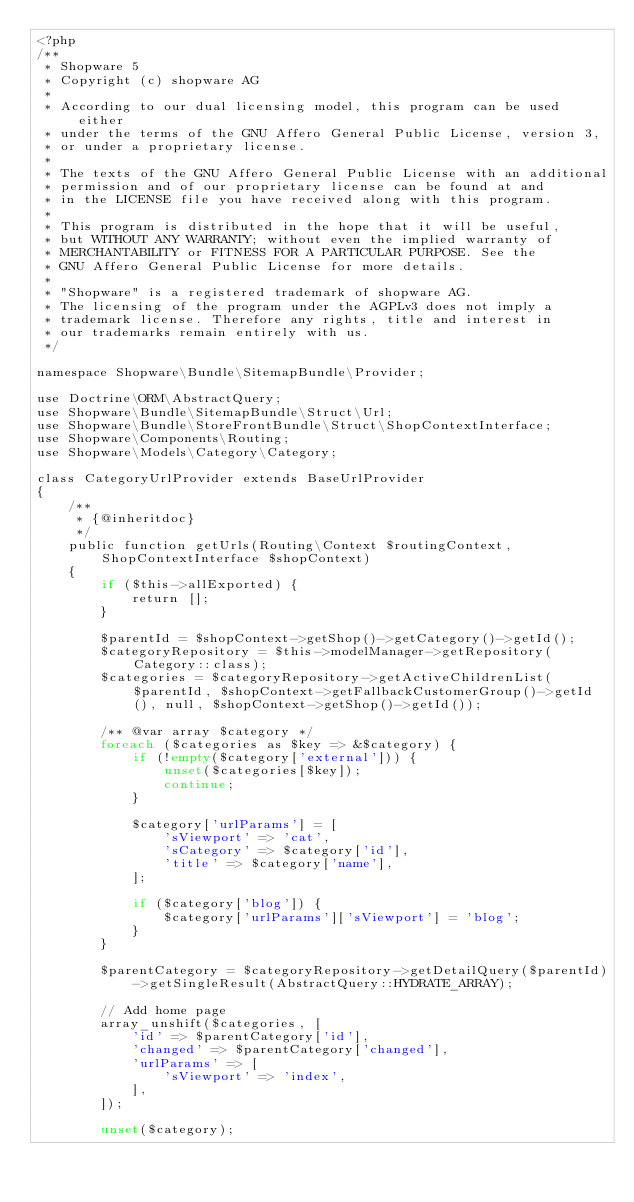Convert code to text. <code><loc_0><loc_0><loc_500><loc_500><_PHP_><?php
/**
 * Shopware 5
 * Copyright (c) shopware AG
 *
 * According to our dual licensing model, this program can be used either
 * under the terms of the GNU Affero General Public License, version 3,
 * or under a proprietary license.
 *
 * The texts of the GNU Affero General Public License with an additional
 * permission and of our proprietary license can be found at and
 * in the LICENSE file you have received along with this program.
 *
 * This program is distributed in the hope that it will be useful,
 * but WITHOUT ANY WARRANTY; without even the implied warranty of
 * MERCHANTABILITY or FITNESS FOR A PARTICULAR PURPOSE. See the
 * GNU Affero General Public License for more details.
 *
 * "Shopware" is a registered trademark of shopware AG.
 * The licensing of the program under the AGPLv3 does not imply a
 * trademark license. Therefore any rights, title and interest in
 * our trademarks remain entirely with us.
 */

namespace Shopware\Bundle\SitemapBundle\Provider;

use Doctrine\ORM\AbstractQuery;
use Shopware\Bundle\SitemapBundle\Struct\Url;
use Shopware\Bundle\StoreFrontBundle\Struct\ShopContextInterface;
use Shopware\Components\Routing;
use Shopware\Models\Category\Category;

class CategoryUrlProvider extends BaseUrlProvider
{
    /**
     * {@inheritdoc}
     */
    public function getUrls(Routing\Context $routingContext, ShopContextInterface $shopContext)
    {
        if ($this->allExported) {
            return [];
        }

        $parentId = $shopContext->getShop()->getCategory()->getId();
        $categoryRepository = $this->modelManager->getRepository(Category::class);
        $categories = $categoryRepository->getActiveChildrenList($parentId, $shopContext->getFallbackCustomerGroup()->getId(), null, $shopContext->getShop()->getId());

        /** @var array $category */
        foreach ($categories as $key => &$category) {
            if (!empty($category['external'])) {
                unset($categories[$key]);
                continue;
            }

            $category['urlParams'] = [
                'sViewport' => 'cat',
                'sCategory' => $category['id'],
                'title' => $category['name'],
            ];

            if ($category['blog']) {
                $category['urlParams']['sViewport'] = 'blog';
            }
        }

        $parentCategory = $categoryRepository->getDetailQuery($parentId)->getSingleResult(AbstractQuery::HYDRATE_ARRAY);

        // Add home page
        array_unshift($categories, [
            'id' => $parentCategory['id'],
            'changed' => $parentCategory['changed'],
            'urlParams' => [
                'sViewport' => 'index',
            ],
        ]);

        unset($category);
</code> 